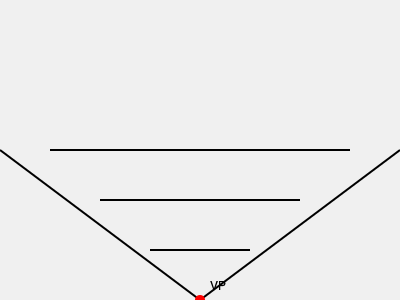In a one-point perspective drawing of a Cuban street scene for your independent film storyboard, you've placed the vanishing point (VP) at the center bottom of your canvas. If you draw three horizontal lines representing buildings at different distances, how would their lengths compare to each other as they get closer to the vanishing point? To understand this, let's break it down step-by-step:

1. In a one-point perspective drawing, all parallel lines that are perpendicular to the picture plane converge at the vanishing point.

2. The horizontal lines in this case represent the edges of buildings at different distances from the viewer.

3. As objects get farther away in a perspective drawing, they appear smaller. This is represented by the horizontal lines getting shorter as they approach the vanishing point.

4. In the diagram:
   - The bottom line (farthest from VP) is the longest
   - The middle line is shorter
   - The top line (closest to VP) is the shortest

5. This creates a proportional relationship:
   Let $l_1$, $l_2$, and $l_3$ be the lengths of the lines from bottom to top.
   Then, $l_1 > l_2 > l_3$

6. The ratio of these lengths depends on their distance from the vanishing point. If we measure the distance from the VP to each line as $d_1$, $d_2$, and $d_3$, then:

   $\frac{l_1}{l_2} = \frac{d_1}{d_2}$ and $\frac{l_2}{l_3} = \frac{d_2}{d_3}$

This relationship creates the illusion of depth and distance in your Cuban street scene storyboard.
Answer: The horizontal lines get progressively shorter as they approach the vanishing point. 